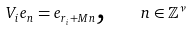Convert formula to latex. <formula><loc_0><loc_0><loc_500><loc_500>V _ { i } e _ { n } = e _ { r _ { i } + M n } \text {,\quad } n \in \mathbb { Z } ^ { \nu }</formula> 